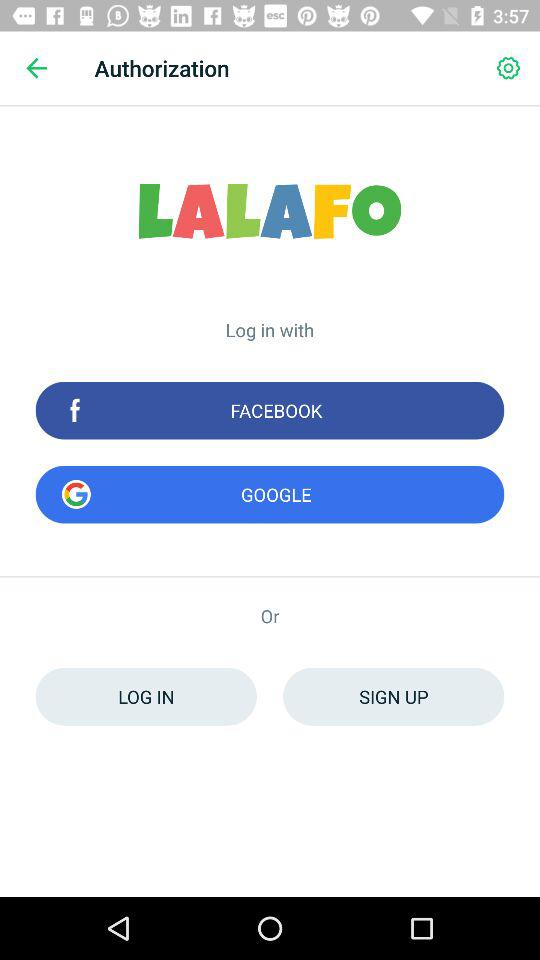How many social media providers are available to log in with?
Answer the question using a single word or phrase. 2 